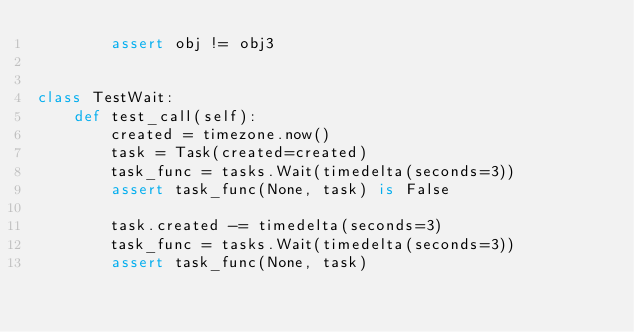Convert code to text. <code><loc_0><loc_0><loc_500><loc_500><_Python_>        assert obj != obj3


class TestWait:
    def test_call(self):
        created = timezone.now()
        task = Task(created=created)
        task_func = tasks.Wait(timedelta(seconds=3))
        assert task_func(None, task) is False

        task.created -= timedelta(seconds=3)
        task_func = tasks.Wait(timedelta(seconds=3))
        assert task_func(None, task)
</code> 